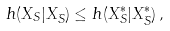<formula> <loc_0><loc_0><loc_500><loc_500>h ( X _ { S } | X _ { \bar { S } } ) \leq h ( X _ { S } ^ { * } | X _ { \bar { S } } ^ { * } ) \, ,</formula> 